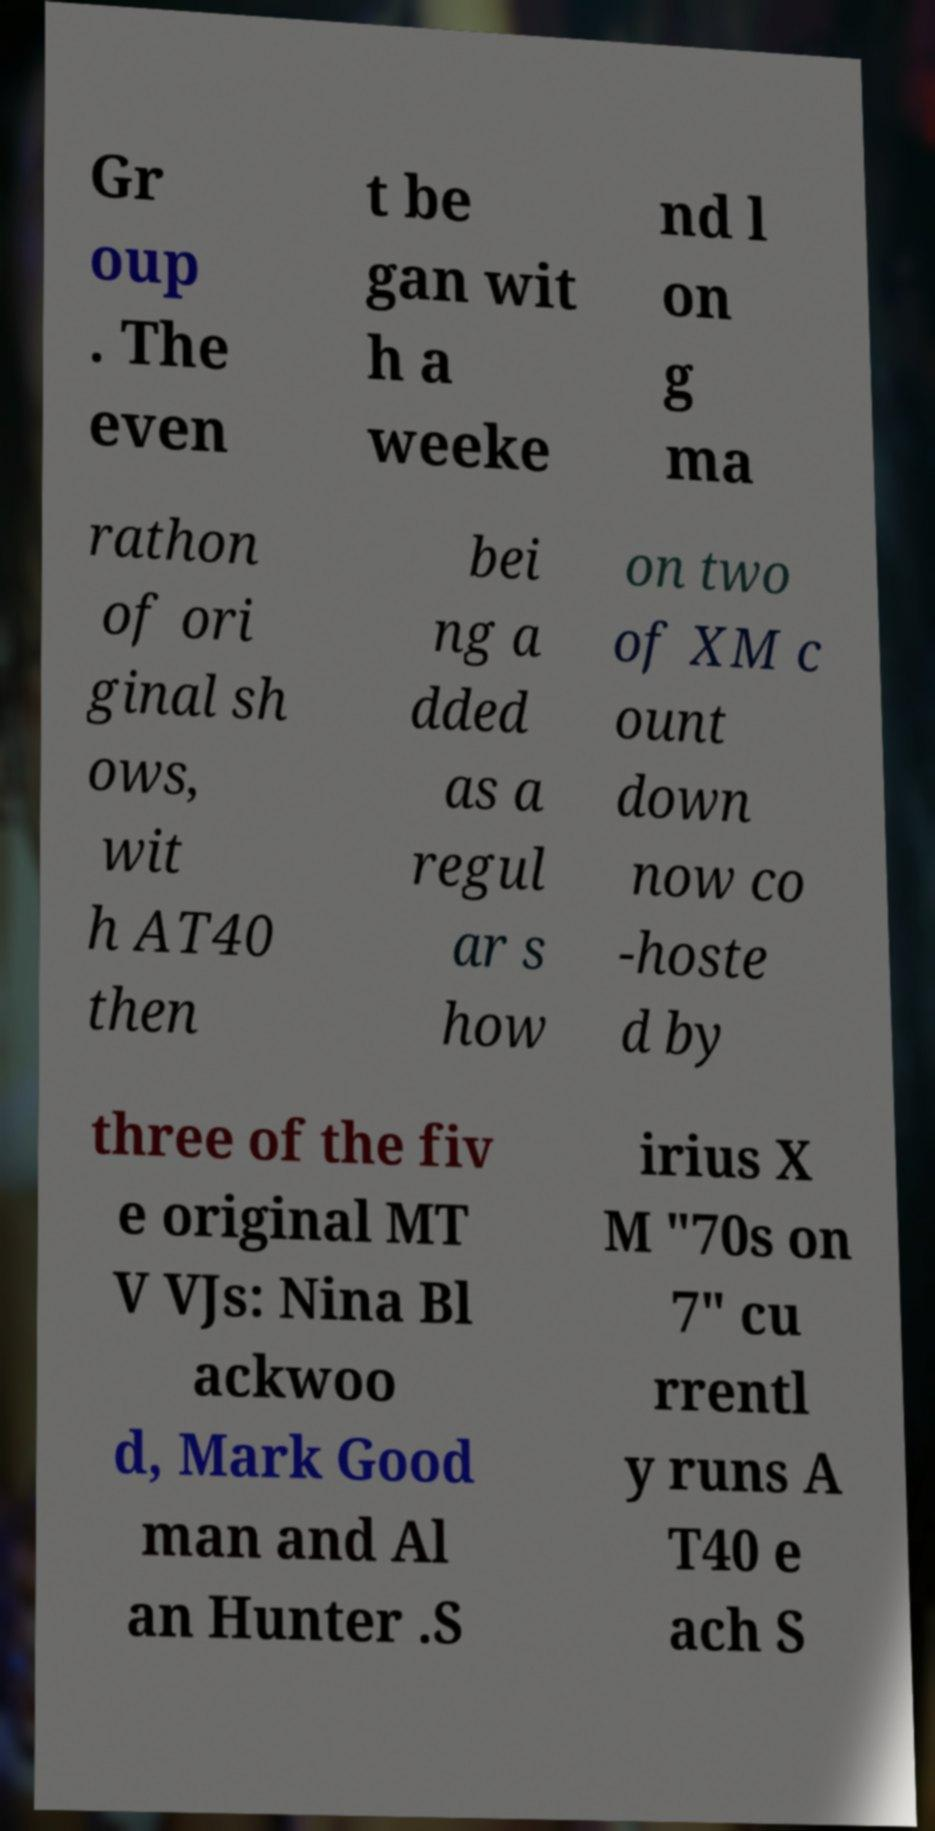What messages or text are displayed in this image? I need them in a readable, typed format. Gr oup . The even t be gan wit h a weeke nd l on g ma rathon of ori ginal sh ows, wit h AT40 then bei ng a dded as a regul ar s how on two of XM c ount down now co -hoste d by three of the fiv e original MT V VJs: Nina Bl ackwoo d, Mark Good man and Al an Hunter .S irius X M "70s on 7" cu rrentl y runs A T40 e ach S 